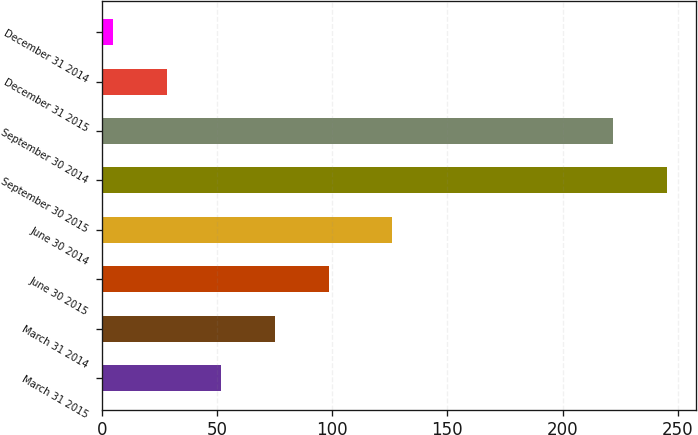Convert chart. <chart><loc_0><loc_0><loc_500><loc_500><bar_chart><fcel>March 31 2015<fcel>March 31 2014<fcel>June 30 2015<fcel>June 30 2014<fcel>September 30 2015<fcel>September 30 2014<fcel>December 31 2015<fcel>December 31 2014<nl><fcel>51.8<fcel>75.2<fcel>98.6<fcel>126<fcel>245.4<fcel>222<fcel>28.4<fcel>5<nl></chart> 